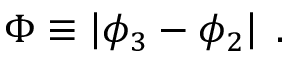<formula> <loc_0><loc_0><loc_500><loc_500>\Phi \equiv \left | \phi _ { 3 } - \phi _ { 2 } \right | \, .</formula> 